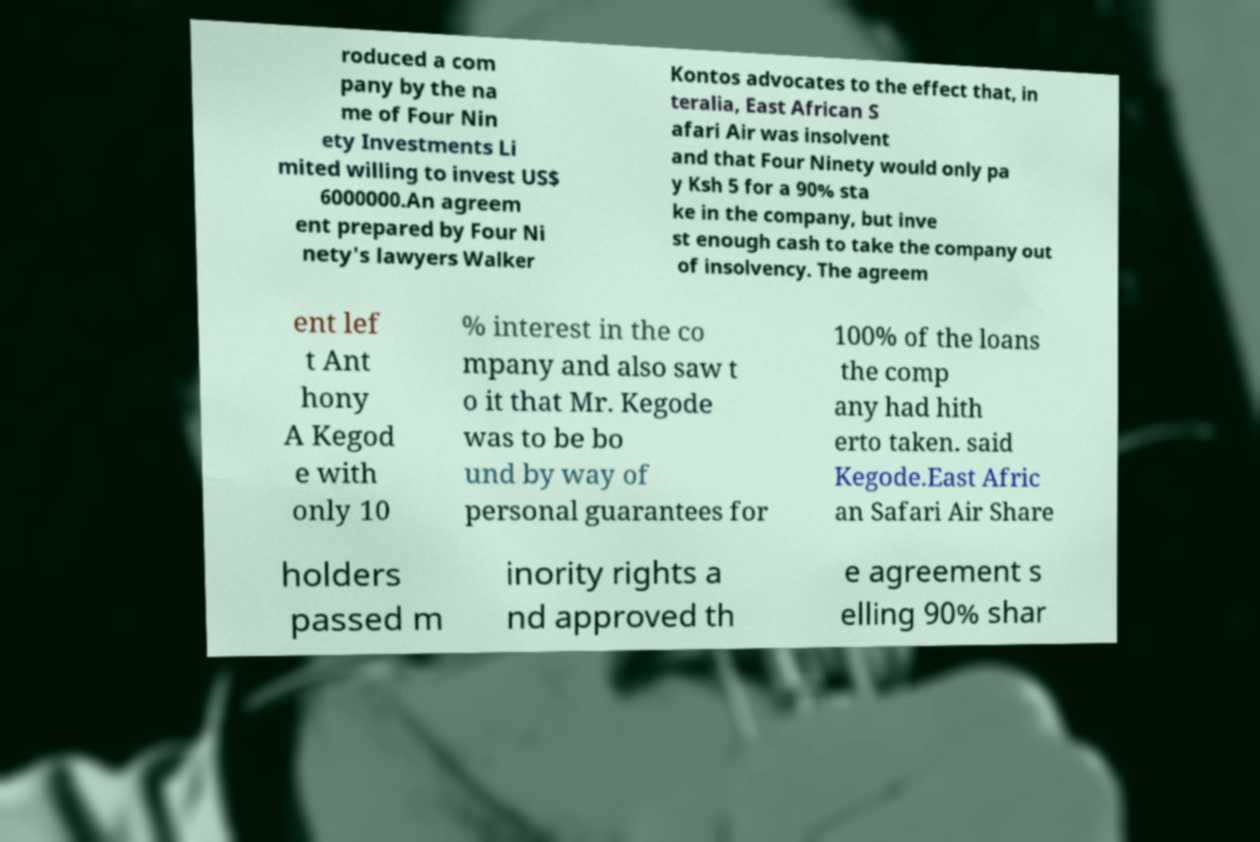Could you assist in decoding the text presented in this image and type it out clearly? roduced a com pany by the na me of Four Nin ety Investments Li mited willing to invest US$ 6000000.An agreem ent prepared by Four Ni nety's lawyers Walker Kontos advocates to the effect that, in teralia, East African S afari Air was insolvent and that Four Ninety would only pa y Ksh 5 for a 90% sta ke in the company, but inve st enough cash to take the company out of insolvency. The agreem ent lef t Ant hony A Kegod e with only 10 % interest in the co mpany and also saw t o it that Mr. Kegode was to be bo und by way of personal guarantees for 100% of the loans the comp any had hith erto taken. said Kegode.East Afric an Safari Air Share holders passed m inority rights a nd approved th e agreement s elling 90% shar 